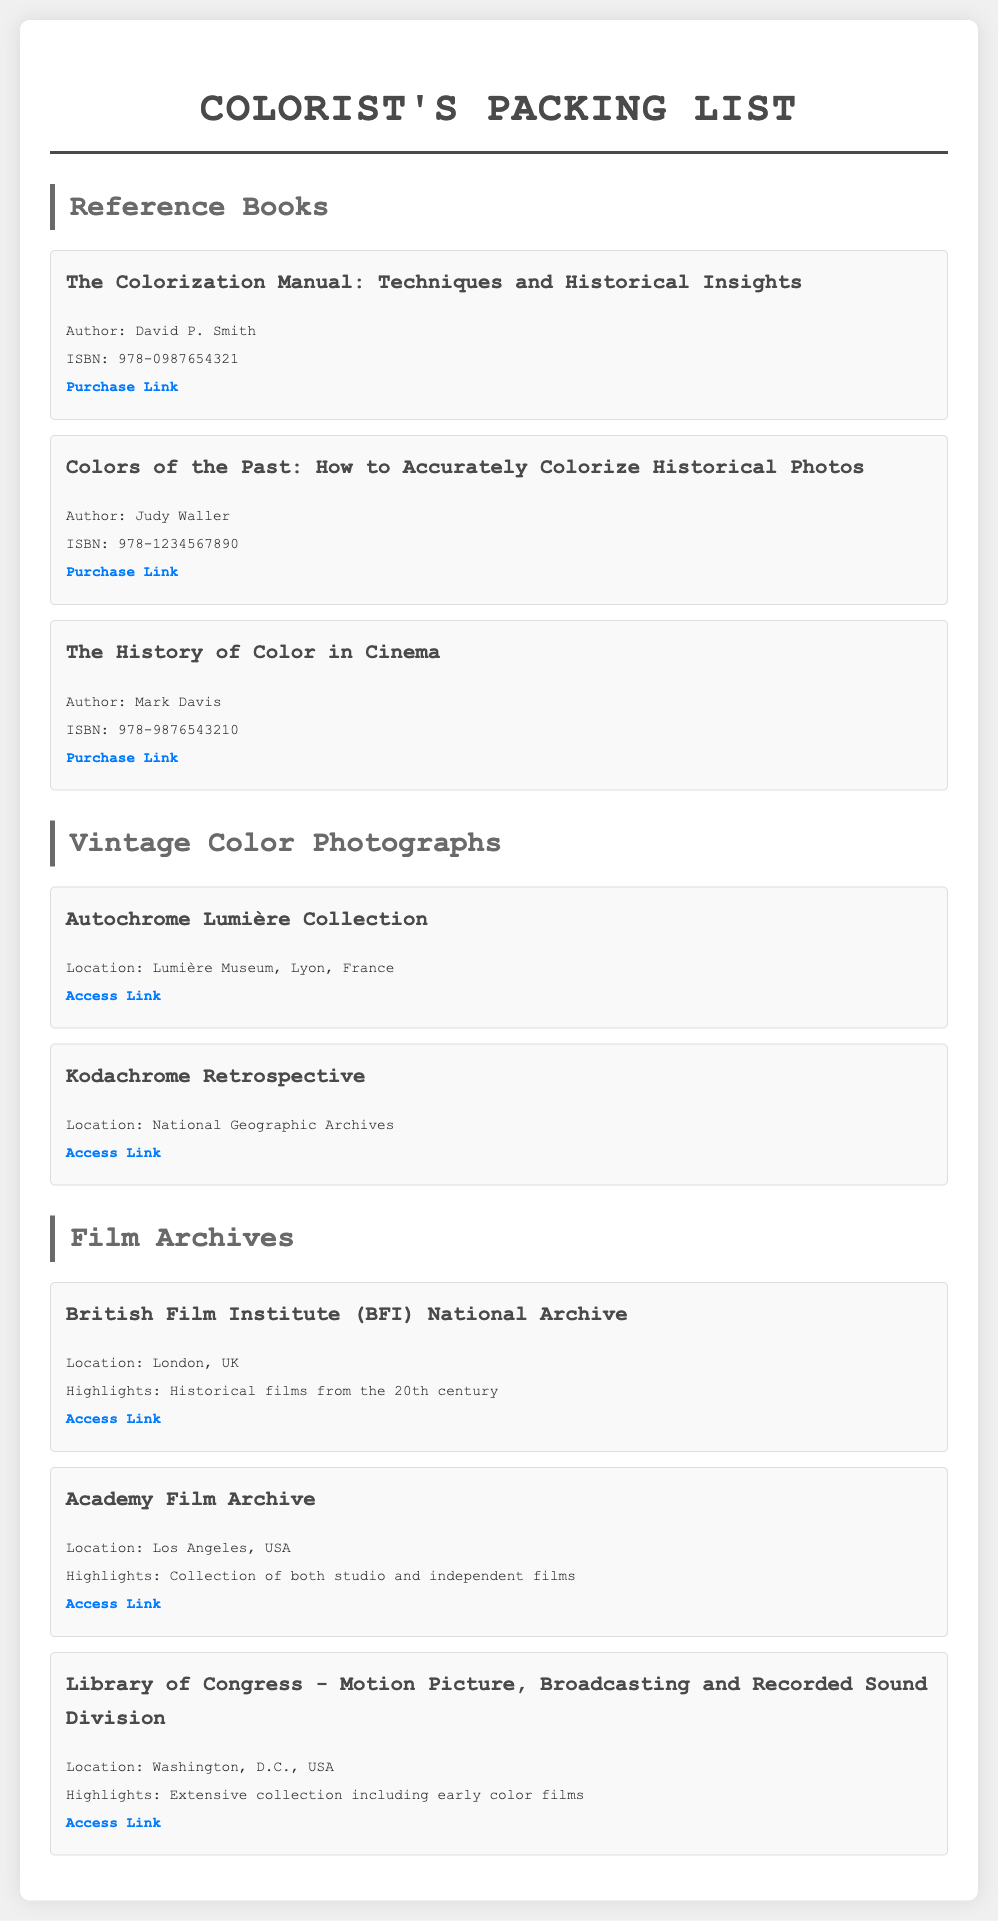What is the title of the book by David P. Smith? The title can be found in the reference books section and is specifically stated.
Answer: The Colorization Manual: Techniques and Historical Insights Who is the author of the book "Colors of the Past"? The author is listed under the book details in the reference section.
Answer: Judy Waller What is the ISBN of "The History of Color in Cinema"? The ISBN is a specific identifier that is provided for the book in the document.
Answer: 978-9876543210 Where is the Autochrome Lumière Collection located? The location is mentioned in the vintage color photographs section, providing a specific museum name and city.
Answer: Lumière Museum, Lyon, France What highlights are associated with the Academy Film Archive? The document gives specific highlights for each film archive listed, showing what they are known for.
Answer: Collection of both studio and independent films How many vintage color photographs are listed in the document? The number can be determined by counting the items in the vintage color photographs section.
Answer: 2 Which archive has historical films from the 20th century? The question requires reasoning to connect the archive name with its highlights listed in the document.
Answer: British Film Institute (BFI) National Archive What type of document is this list specifically tailored for? The question focuses on the unique purpose of this document as indicated by its overarching title and content.
Answer: Packing list 